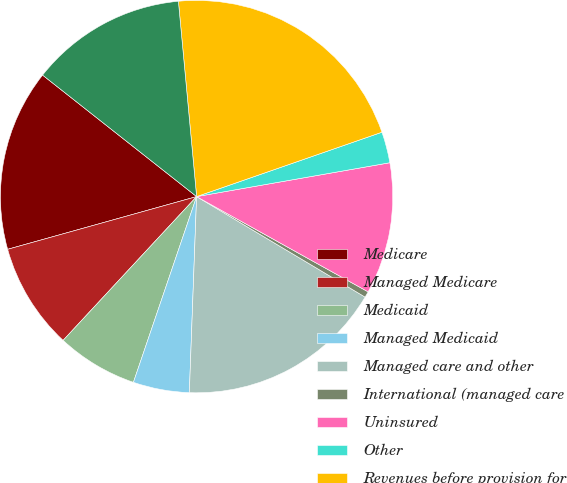Convert chart to OTSL. <chart><loc_0><loc_0><loc_500><loc_500><pie_chart><fcel>Medicare<fcel>Managed Medicare<fcel>Medicaid<fcel>Managed Medicaid<fcel>Managed care and other<fcel>International (managed care<fcel>Uninsured<fcel>Other<fcel>Revenues before provision for<fcel>Provision for doubtful<nl><fcel>14.96%<fcel>8.76%<fcel>6.69%<fcel>4.63%<fcel>17.03%<fcel>0.49%<fcel>10.83%<fcel>2.56%<fcel>21.16%<fcel>12.89%<nl></chart> 